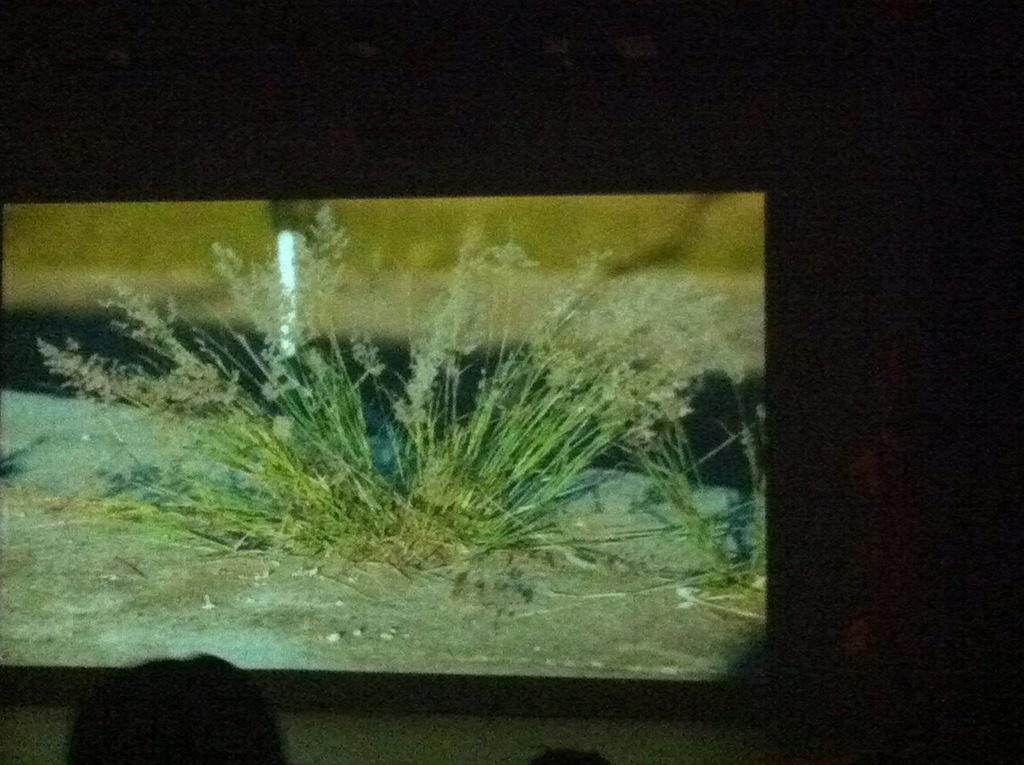What is shown on the screen in the image? The image displayed on the screen shows grass. What is the color of the background on the screen? The background of the screen is dark. Can you see any writing on the grass in the image? There is no writing visible on the grass in the image. 